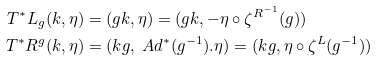<formula> <loc_0><loc_0><loc_500><loc_500>T ^ { * } L _ { g } ( k , \eta ) & = ( g k , \eta ) = ( g k , - \eta \circ \zeta ^ { R ^ { - 1 } } ( g ) ) \\ T ^ { * } R ^ { g } ( k , \eta ) & = ( k g , \ A d ^ { * } ( g ^ { - 1 } ) . \eta ) = ( k g , \eta \circ \zeta ^ { L } ( g ^ { - 1 } ) )</formula> 